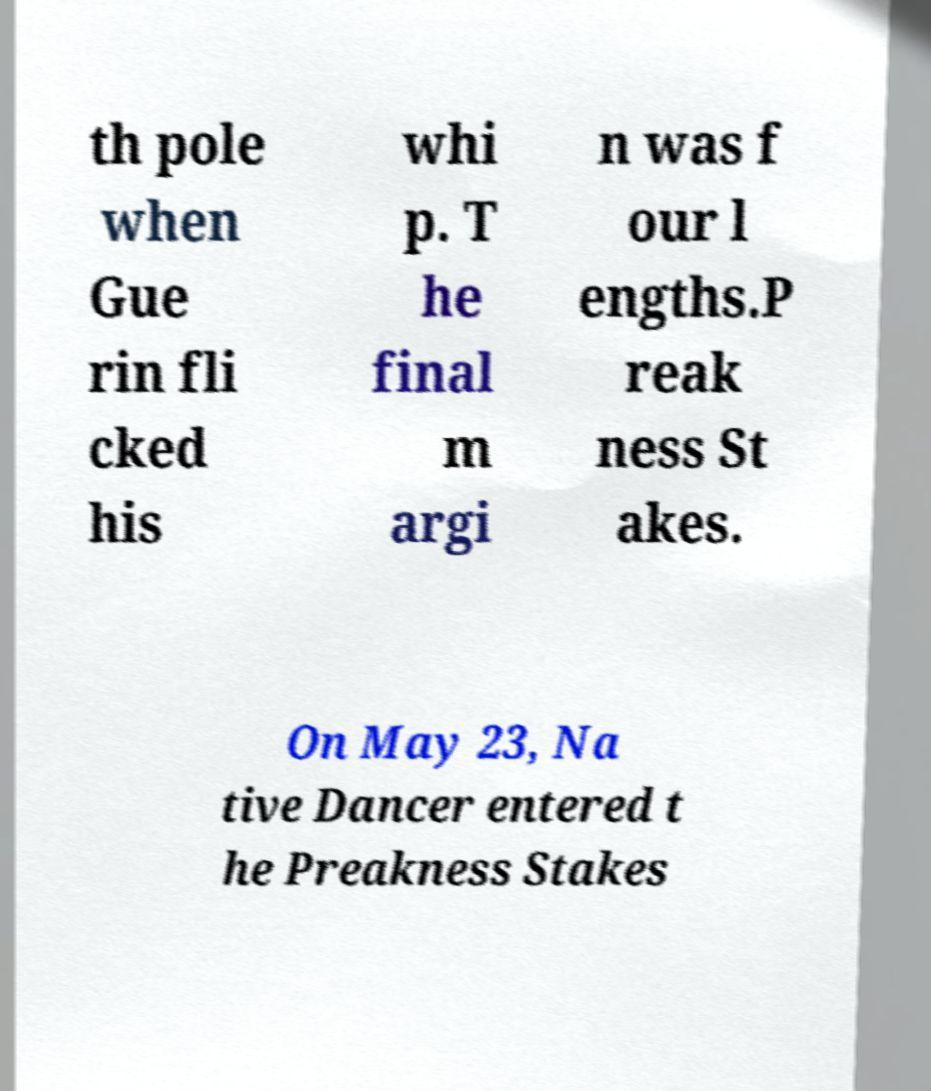Could you extract and type out the text from this image? th pole when Gue rin fli cked his whi p. T he final m argi n was f our l engths.P reak ness St akes. On May 23, Na tive Dancer entered t he Preakness Stakes 